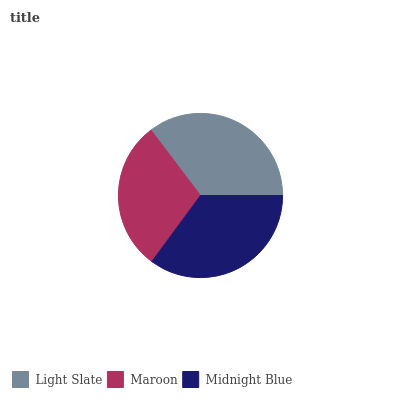Is Maroon the minimum?
Answer yes or no. Yes. Is Light Slate the maximum?
Answer yes or no. Yes. Is Midnight Blue the minimum?
Answer yes or no. No. Is Midnight Blue the maximum?
Answer yes or no. No. Is Midnight Blue greater than Maroon?
Answer yes or no. Yes. Is Maroon less than Midnight Blue?
Answer yes or no. Yes. Is Maroon greater than Midnight Blue?
Answer yes or no. No. Is Midnight Blue less than Maroon?
Answer yes or no. No. Is Midnight Blue the high median?
Answer yes or no. Yes. Is Midnight Blue the low median?
Answer yes or no. Yes. Is Maroon the high median?
Answer yes or no. No. Is Maroon the low median?
Answer yes or no. No. 